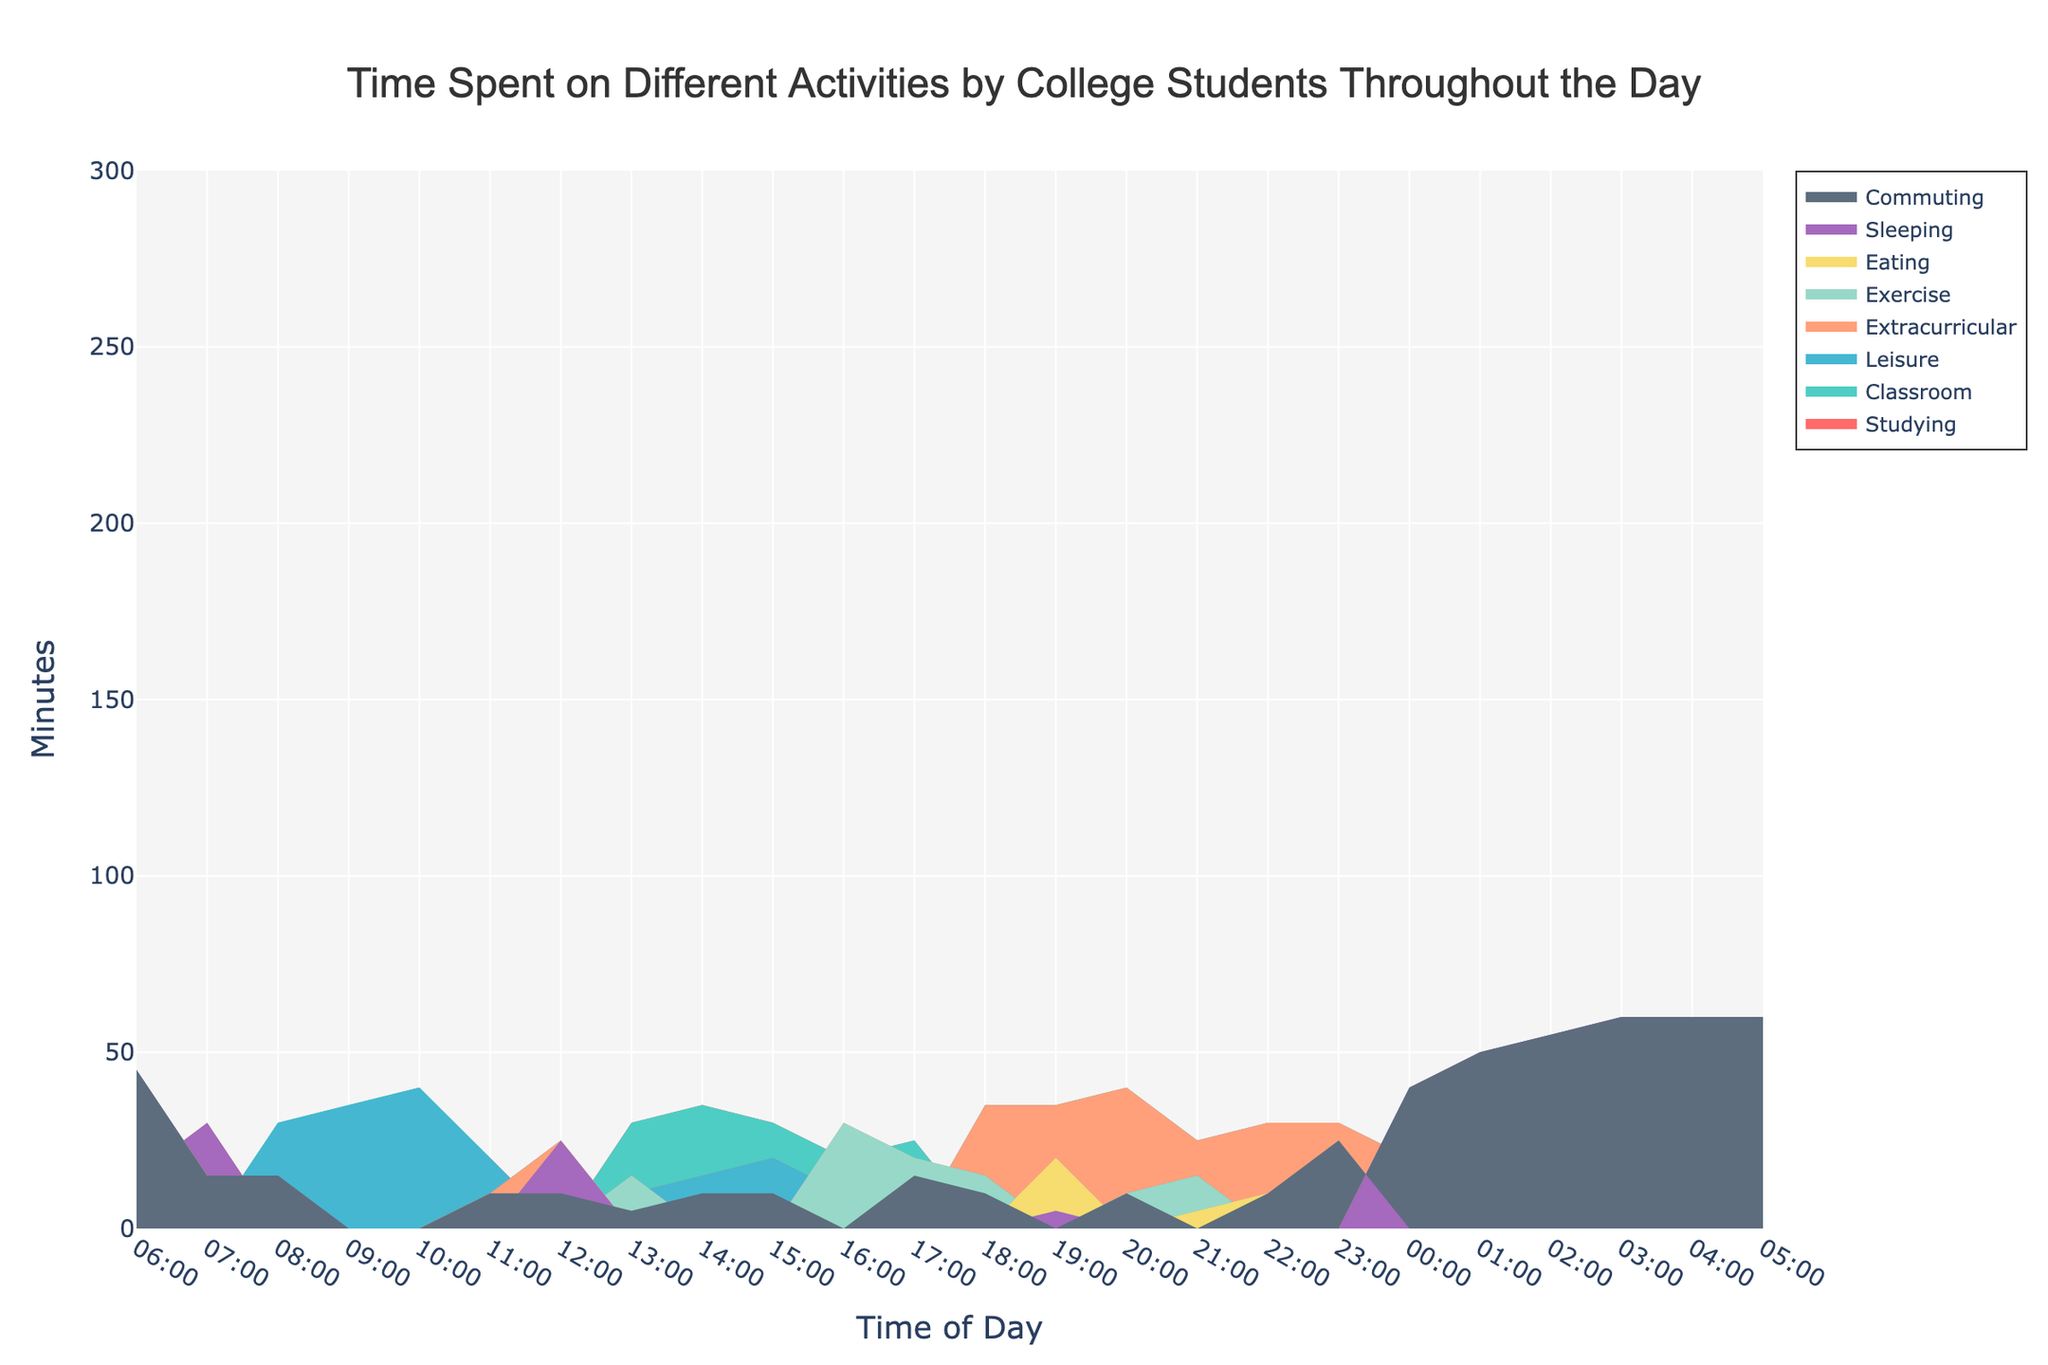what is the title of the figure? The title is located at the top of the figure, centered, and is usually written in larger and more noticeable font compared to other text elements.
Answer: Time Spent on Different Activities by College Students Throughout the Day what time of the day has the highest number of minutes spent studying? To find this, look at the 'Studying' area in the chart and identify the peak value along the x-axis corresponding to time.
Answer: 14:00 which activity has the greatest time spent during the 22:00 hour? Look at the portion of the area chart for 22:00. The activity with the largest filled area vertically is the one with the greatest time spent.
Answer: Leisure how does the time spent on leisure compare between 08:00 and 21:00? Observe the 'Leisure' filled area values at 08:00 and 21:00. The comparison requires looking at these specific times and noting the height of the leisure area.
Answer: 0 minutes (08:00), 25 minutes (21:00) which activities have no time spent on them during the 12:00 hour? At 12:00, check for the activities that have a zero or missing area in the chart, which indicates no time spent.
Answer: Studying, Classroom, Extracurricular, Exercise what is the total time spent on eating from 00:00 to 05:00 inclusive? Sum the values of the 'Eating' activity from 00:00 to 05:00 by identifying the values at these times and adding them together.
Answer: 15 minutes between 20:00 and 00:00, which activity shows a decreasing trend? Look for the activity whose area starts larger at 20:00 and goes down by 00:00. Identify the trend by examining the graphical decrease in area.
Answer: Leisure what is the average time spent sleeping from 00:00 to 05:00? Sum the sleeping minutes from 00:00 to 05:00 and divide by the number of time points (6). corresponds to (40 + 50 + 55 + 60 + 60 + 60) / 6
Answer: 54.17 minutes how many activities are represented in the figure? Count the number of distinct areas (color segments) in the chart, each representing a different activity.
Answer: 8 which activity shows a consistent amount of time spent from 03:00 to 05:00? Find the section of the chart from 03:00 to 05:00 and identify any activity where the area height remains constant.
Answer: Sleeping 